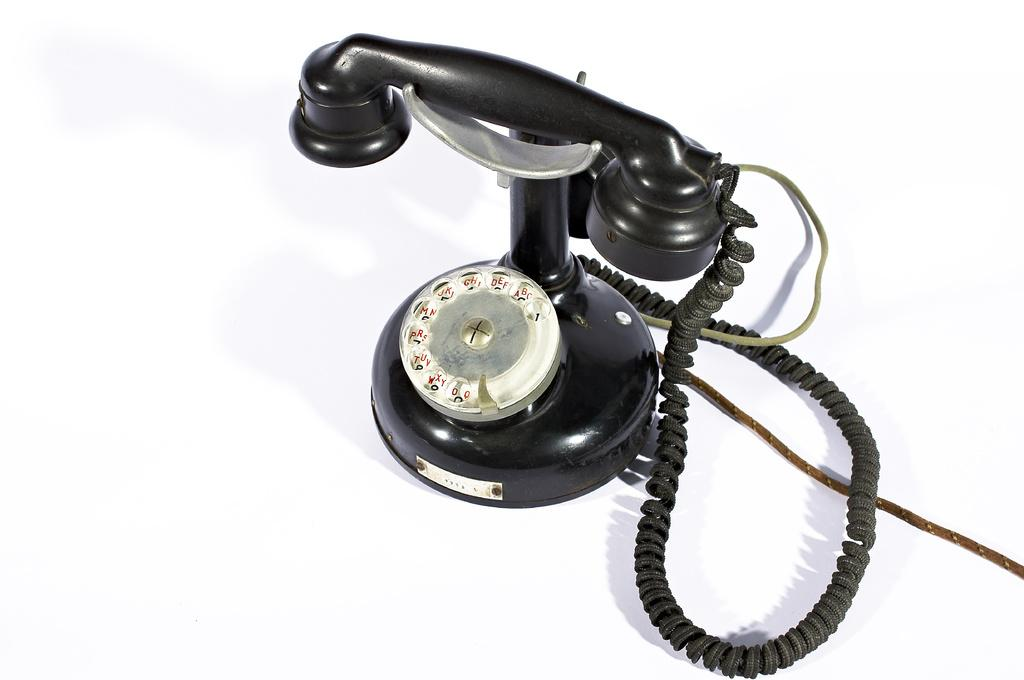What object is the main focus of the image? There is a telephone in the image. What else can be seen in the image besides the telephone? There are cables in the image. What is the color of the surface on which the telephone and cables are placed? The telephone and cables are on a white surface. What is the color of the background in the image? The background of the image is white. What type of pet can be seen comforting the telephone in the image? There is no pet present in the image, and the telephone does not require comforting. 